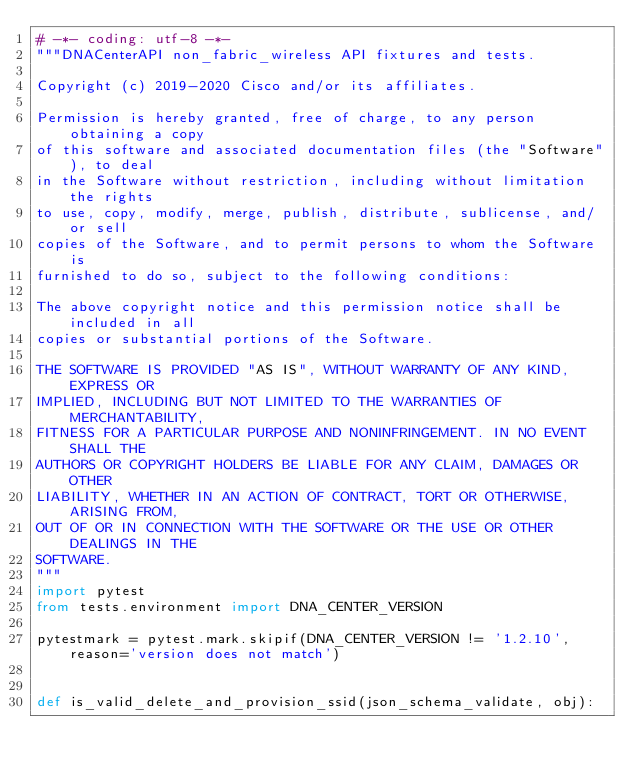Convert code to text. <code><loc_0><loc_0><loc_500><loc_500><_Python_># -*- coding: utf-8 -*-
"""DNACenterAPI non_fabric_wireless API fixtures and tests.

Copyright (c) 2019-2020 Cisco and/or its affiliates.

Permission is hereby granted, free of charge, to any person obtaining a copy
of this software and associated documentation files (the "Software"), to deal
in the Software without restriction, including without limitation the rights
to use, copy, modify, merge, publish, distribute, sublicense, and/or sell
copies of the Software, and to permit persons to whom the Software is
furnished to do so, subject to the following conditions:

The above copyright notice and this permission notice shall be included in all
copies or substantial portions of the Software.

THE SOFTWARE IS PROVIDED "AS IS", WITHOUT WARRANTY OF ANY KIND, EXPRESS OR
IMPLIED, INCLUDING BUT NOT LIMITED TO THE WARRANTIES OF MERCHANTABILITY,
FITNESS FOR A PARTICULAR PURPOSE AND NONINFRINGEMENT. IN NO EVENT SHALL THE
AUTHORS OR COPYRIGHT HOLDERS BE LIABLE FOR ANY CLAIM, DAMAGES OR OTHER
LIABILITY, WHETHER IN AN ACTION OF CONTRACT, TORT OR OTHERWISE, ARISING FROM,
OUT OF OR IN CONNECTION WITH THE SOFTWARE OR THE USE OR OTHER DEALINGS IN THE
SOFTWARE.
"""
import pytest
from tests.environment import DNA_CENTER_VERSION

pytestmark = pytest.mark.skipif(DNA_CENTER_VERSION != '1.2.10', reason='version does not match')


def is_valid_delete_and_provision_ssid(json_schema_validate, obj):</code> 